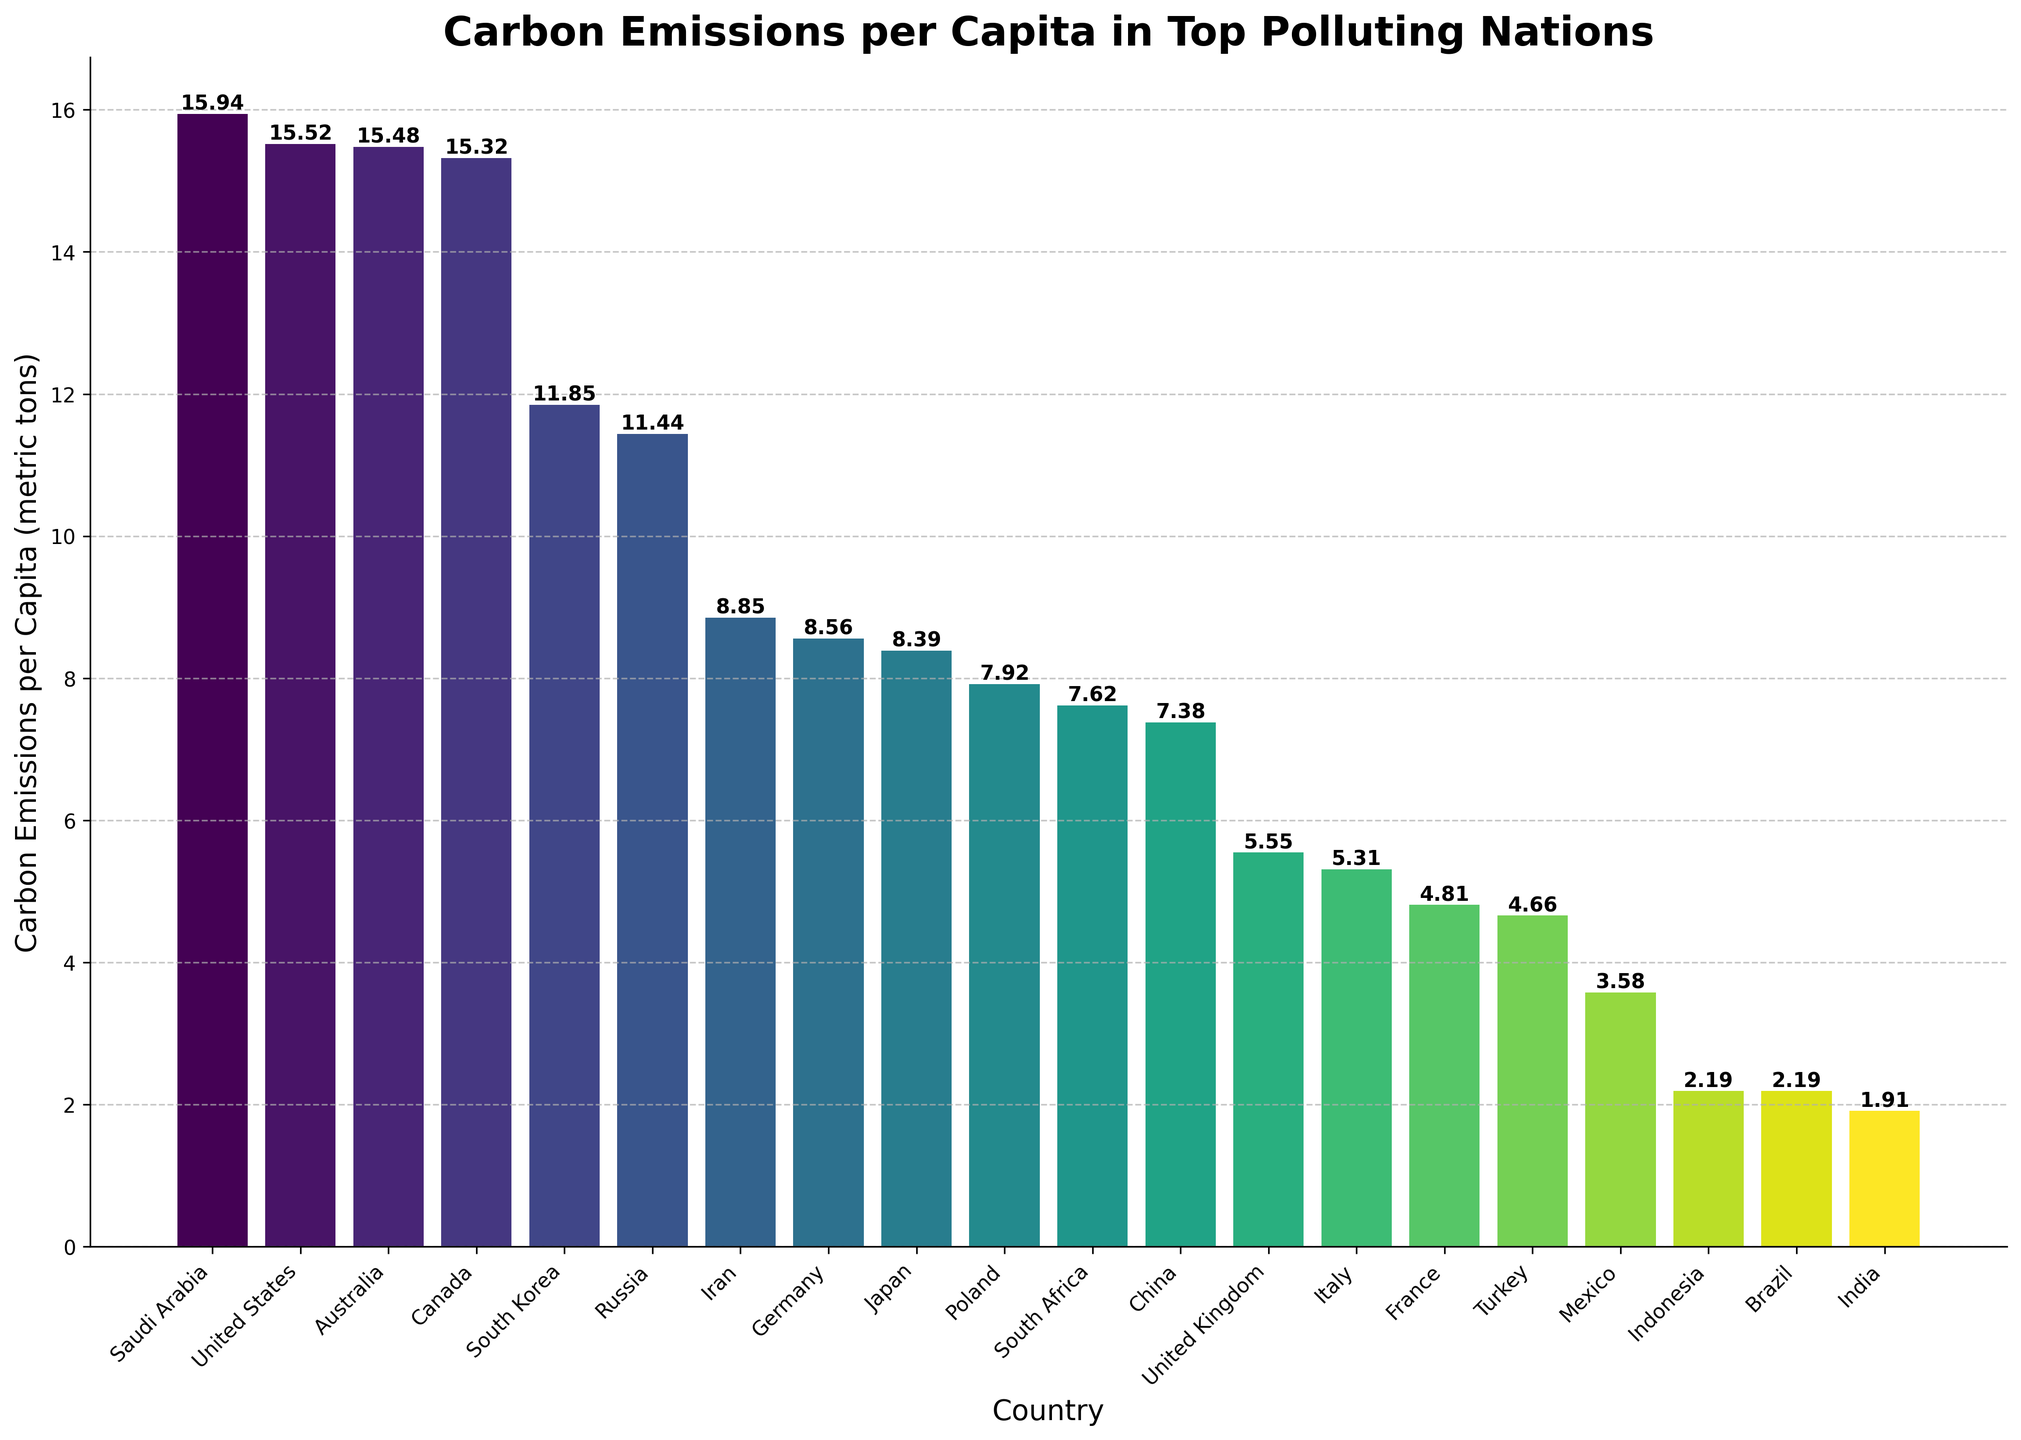Which country has the highest carbon emissions per capita? By looking at the top of the bar chart, we can see that Saudi Arabia has the highest carbon emissions per capita.
Answer: Saudi Arabia Which country has the lowest carbon emissions per capita? By looking at the bottom of the bar chart, we can see that India has the lowest carbon emissions per capita.
Answer: India How do the carbon emissions per capita of China and the United States compare? We need to compare the heights of the bars for China and the United States. The bar for the United States is taller than the bar for China, indicating that the United States has higher carbon emissions per capita than China.
Answer: The United States has higher emissions than China What is the difference in carbon emissions per capita between Saudi Arabia and India? Find the heights of the bars for Saudi Arabia (15.94 metric tons) and India (1.91 metric tons), and subtract India's value from Saudi Arabia's value: 15.94 - 1.91 = 14.03 metric tons.
Answer: 14.03 metric tons Which countries have carbon emissions per capita greater than 10 metric tons? Look for the bars taller than the 10 metric tons mark. These countries are the United States, Russia, South Korea, and Saudi Arabia.
Answer: United States, Russia, South Korea, Saudi Arabia What is the average carbon emissions per capita among Brazil, Indonesia, and Mexico? Locate the bars for Brazil, Indonesia, and Mexico and find their heights: Brazil (2.19), Indonesia (2.19), Mexico (3.58). Calculate the average: (2.19 + 2.19 + 3.58) / 3 = 2.65 metric tons.
Answer: 2.65 metric tons Which country has the closest carbon emissions per capita to the median value of all countries? To find the median, list all countries' emissions per capita values in ascending order and find the middle value or average the two middle values. In this case, the median lies between France (4.81) and Italy (5.31), so the median is around (4.81 + 5.31) / 2 = 5.06 metric tons. The United Kingdom, with emissions at 5.55 metric tons, is closest to 5.06 metric tons.
Answer: United Kingdom How do the carbon emissions per capita of Germany compare to Japan? Compare the heights of Germany's bar (8.56 metric tons) to Japan's bar (8.39 metric tons). The bar for Germany is slightly taller, indicating slightly higher emissions per capita than Japan.
Answer: Germany has slightly higher emissions than Japan What is the combined carbon emissions per capita of Russia and South Korea? Locate the bars for Russia (11.44 metric tons) and South Korea (11.85 metric tons). Add them together: 11.44 + 11.85 = 23.29 metric tons.
Answer: 23.29 metric tons Which European country has the highest carbon emissions per capita? Among the European countries listed (Germany, United Kingdom, Italy, France, Poland), find the one with the tallest bar. Germany, with 8.56 metric tons, has the highest carbon emissions per capita among these countries.
Answer: Germany 